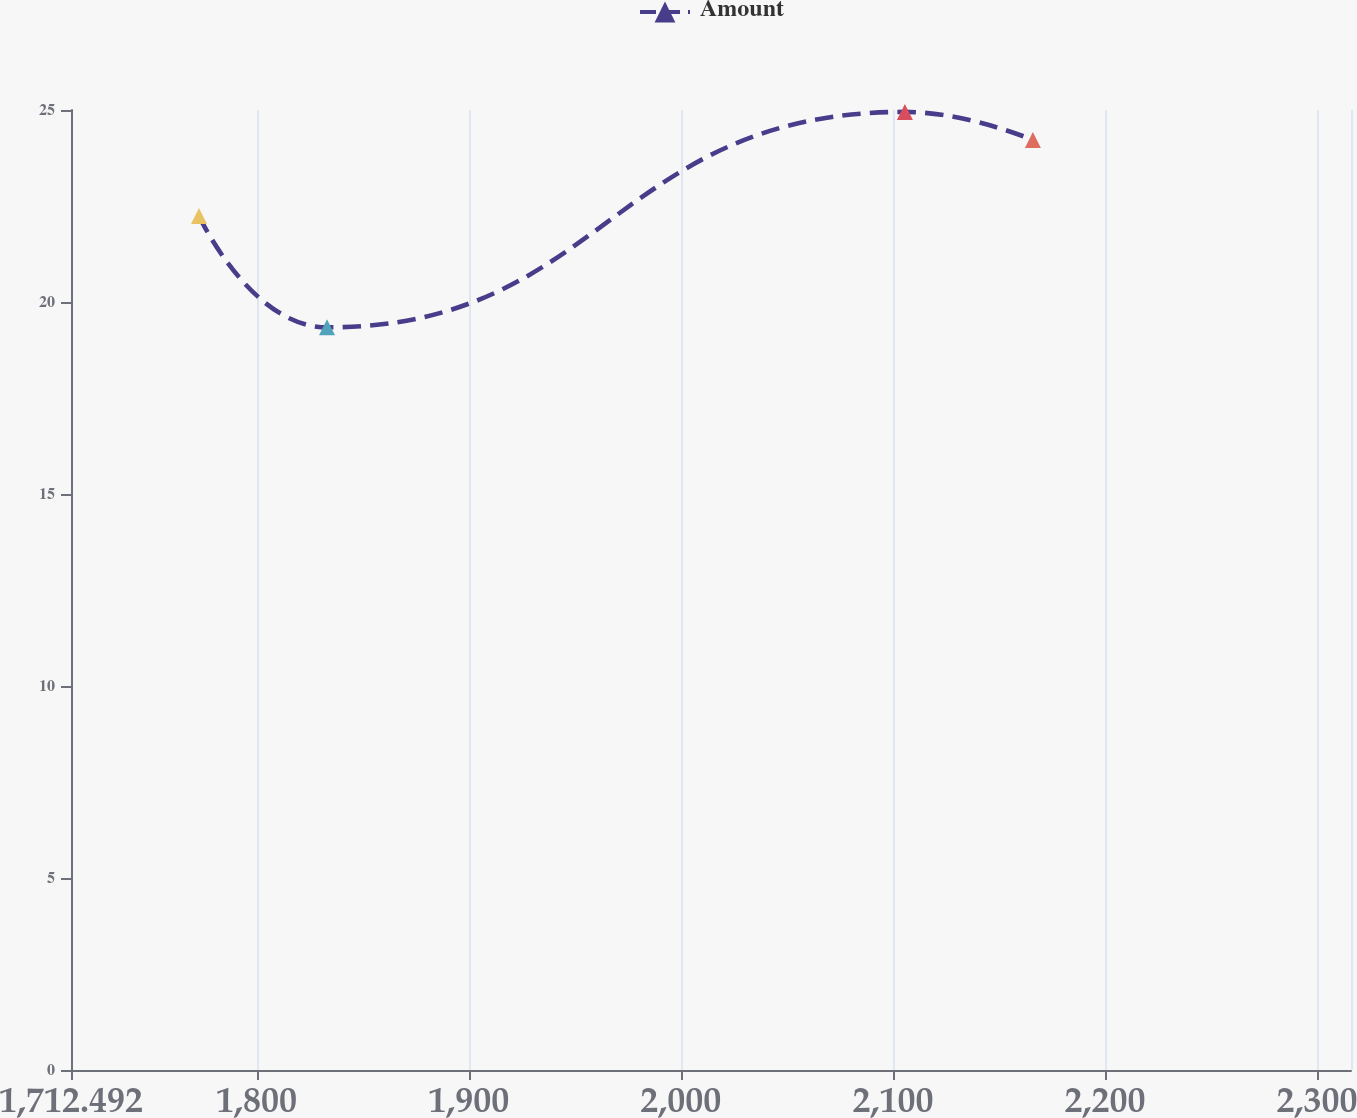Convert chart to OTSL. <chart><loc_0><loc_0><loc_500><loc_500><line_chart><ecel><fcel>Amount<nl><fcel>1772.84<fcel>22.24<nl><fcel>1833.19<fcel>19.34<nl><fcel>2105.64<fcel>24.95<nl><fcel>2165.99<fcel>24.22<nl><fcel>2376.32<fcel>21.68<nl></chart> 